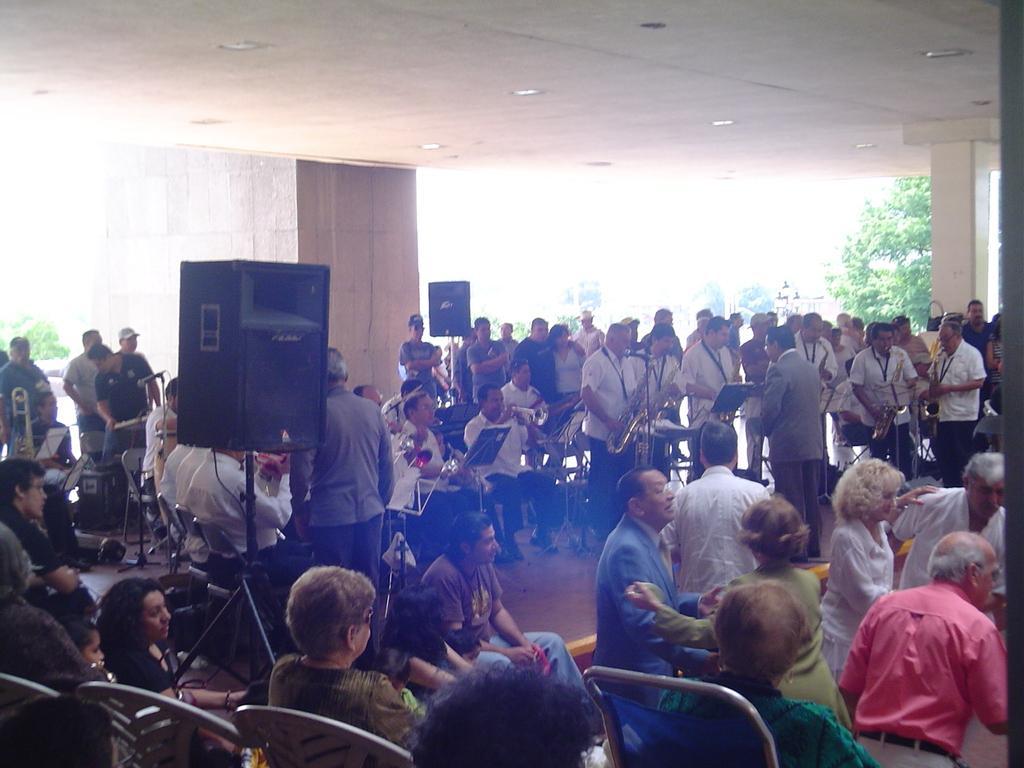How would you summarize this image in a sentence or two? In the picture we can see some people are sitting on the chairs and some people are standing in front of them and beside them we can see some people are standing with musical instruments and behind them we can see a pillar to the ceiling and to the ceiling we can see lights and behind we can see some plants. 